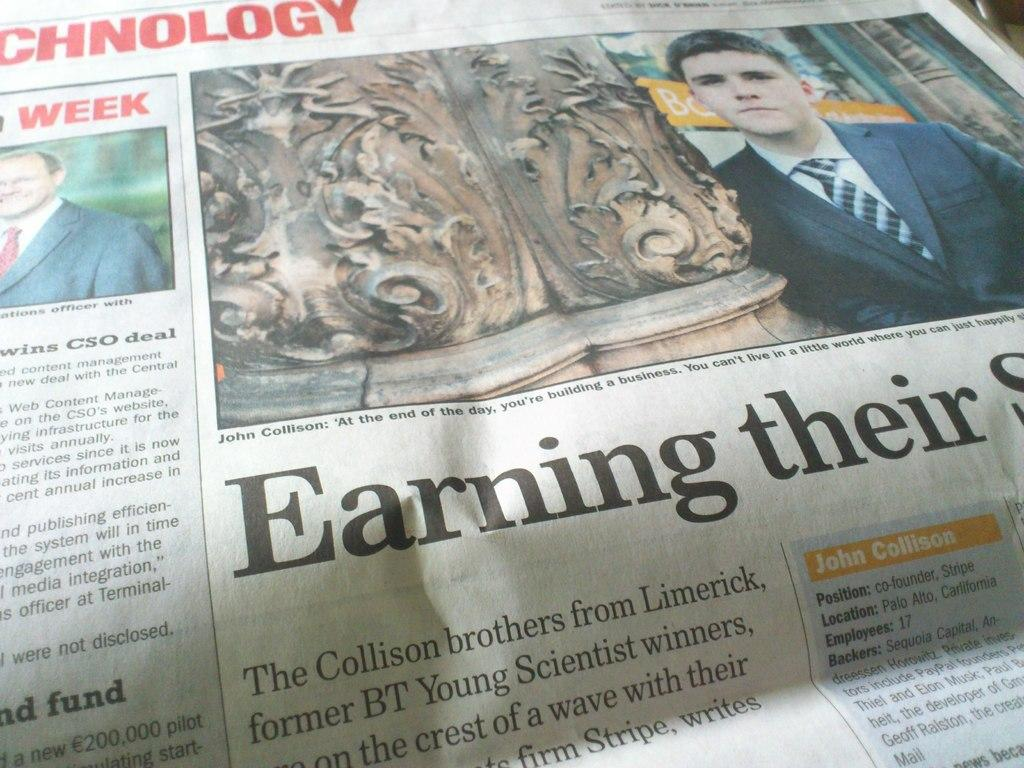What object can be seen in the image that is used for reading? There is a newspaper in the image that is used for reading. What can be found on the newspaper? There is text on the newspaper. How many people are in the image? There are two men in the image. What architectural feature is present in the image? There is a pillar in the image. What type of vase can be seen on the coast in the image? There is no vase or coast present in the image; it features a newspaper, two men, and a pillar. What is the weather like in the image? The provided facts do not mention the weather, so it cannot be determined from the image. 